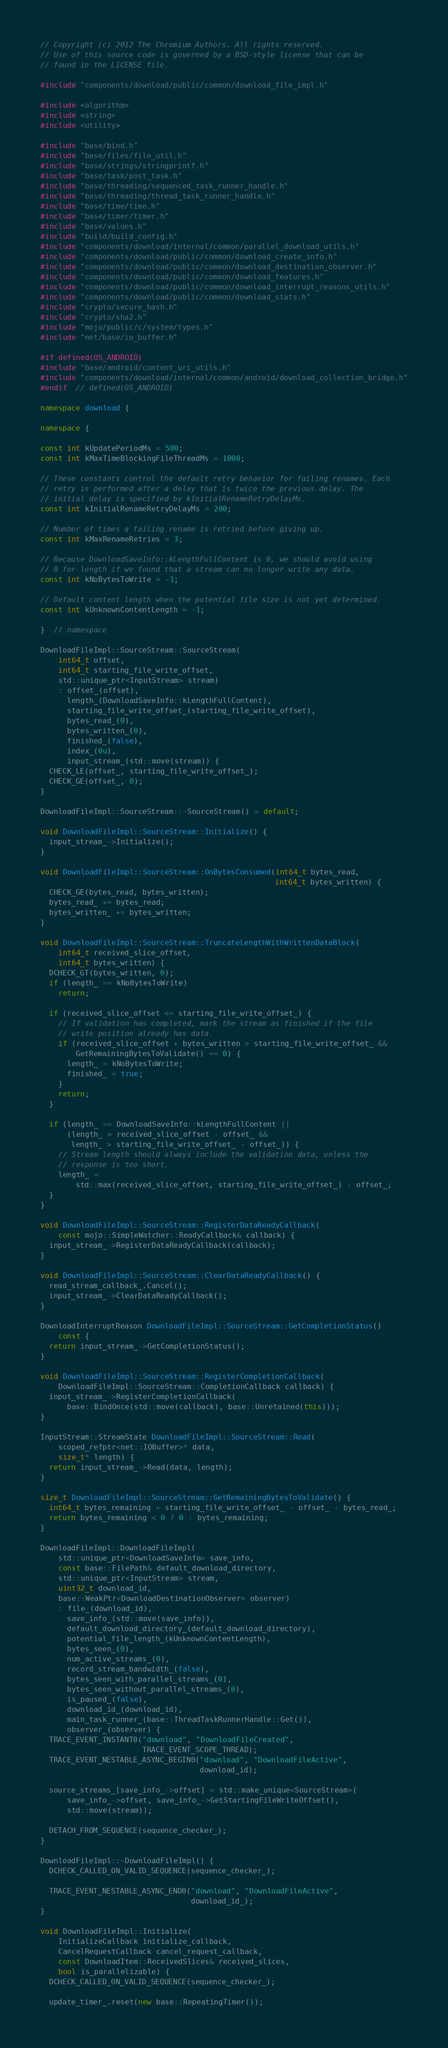Convert code to text. <code><loc_0><loc_0><loc_500><loc_500><_C++_>// Copyright (c) 2012 The Chromium Authors. All rights reserved.
// Use of this source code is governed by a BSD-style license that can be
// found in the LICENSE file.

#include "components/download/public/common/download_file_impl.h"

#include <algorithm>
#include <string>
#include <utility>

#include "base/bind.h"
#include "base/files/file_util.h"
#include "base/strings/stringprintf.h"
#include "base/task/post_task.h"
#include "base/threading/sequenced_task_runner_handle.h"
#include "base/threading/thread_task_runner_handle.h"
#include "base/time/time.h"
#include "base/timer/timer.h"
#include "base/values.h"
#include "build/build_config.h"
#include "components/download/internal/common/parallel_download_utils.h"
#include "components/download/public/common/download_create_info.h"
#include "components/download/public/common/download_destination_observer.h"
#include "components/download/public/common/download_features.h"
#include "components/download/public/common/download_interrupt_reasons_utils.h"
#include "components/download/public/common/download_stats.h"
#include "crypto/secure_hash.h"
#include "crypto/sha2.h"
#include "mojo/public/c/system/types.h"
#include "net/base/io_buffer.h"

#if defined(OS_ANDROID)
#include "base/android/content_uri_utils.h"
#include "components/download/internal/common/android/download_collection_bridge.h"
#endif  // defined(OS_ANDROID)

namespace download {

namespace {

const int kUpdatePeriodMs = 500;
const int kMaxTimeBlockingFileThreadMs = 1000;

// These constants control the default retry behavior for failing renames. Each
// retry is performed after a delay that is twice the previous delay. The
// initial delay is specified by kInitialRenameRetryDelayMs.
const int kInitialRenameRetryDelayMs = 200;

// Number of times a failing rename is retried before giving up.
const int kMaxRenameRetries = 3;

// Because DownloadSaveInfo::kLengthFullContent is 0, we should avoid using
// 0 for length if we found that a stream can no longer write any data.
const int kNoBytesToWrite = -1;

// Default content length when the potential file size is not yet determined.
const int kUnknownContentLength = -1;

}  // namespace

DownloadFileImpl::SourceStream::SourceStream(
    int64_t offset,
    int64_t starting_file_write_offset,
    std::unique_ptr<InputStream> stream)
    : offset_(offset),
      length_(DownloadSaveInfo::kLengthFullContent),
      starting_file_write_offset_(starting_file_write_offset),
      bytes_read_(0),
      bytes_written_(0),
      finished_(false),
      index_(0u),
      input_stream_(std::move(stream)) {
  CHECK_LE(offset_, starting_file_write_offset_);
  CHECK_GE(offset_, 0);
}

DownloadFileImpl::SourceStream::~SourceStream() = default;

void DownloadFileImpl::SourceStream::Initialize() {
  input_stream_->Initialize();
}

void DownloadFileImpl::SourceStream::OnBytesConsumed(int64_t bytes_read,
                                                     int64_t bytes_written) {
  CHECK_GE(bytes_read, bytes_written);
  bytes_read_ += bytes_read;
  bytes_written_ += bytes_written;
}

void DownloadFileImpl::SourceStream::TruncateLengthWithWrittenDataBlock(
    int64_t received_slice_offset,
    int64_t bytes_written) {
  DCHECK_GT(bytes_written, 0);
  if (length_ == kNoBytesToWrite)
    return;

  if (received_slice_offset <= starting_file_write_offset_) {
    // If validation has completed, mark the stream as finished if the file
    // write position already has data.
    if (received_slice_offset + bytes_written > starting_file_write_offset_ &&
        GetRemainingBytesToValidate() == 0) {
      length_ = kNoBytesToWrite;
      finished_ = true;
    }
    return;
  }

  if (length_ == DownloadSaveInfo::kLengthFullContent ||
      (length_ > received_slice_offset - offset_ &&
       length_ > starting_file_write_offset_ - offset_)) {
    // Stream length should always include the validation data, unless the
    // response is too short.
    length_ =
        std::max(received_slice_offset, starting_file_write_offset_) - offset_;
  }
}

void DownloadFileImpl::SourceStream::RegisterDataReadyCallback(
    const mojo::SimpleWatcher::ReadyCallback& callback) {
  input_stream_->RegisterDataReadyCallback(callback);
}

void DownloadFileImpl::SourceStream::ClearDataReadyCallback() {
  read_stream_callback_.Cancel();
  input_stream_->ClearDataReadyCallback();
}

DownloadInterruptReason DownloadFileImpl::SourceStream::GetCompletionStatus()
    const {
  return input_stream_->GetCompletionStatus();
}

void DownloadFileImpl::SourceStream::RegisterCompletionCallback(
    DownloadFileImpl::SourceStream::CompletionCallback callback) {
  input_stream_->RegisterCompletionCallback(
      base::BindOnce(std::move(callback), base::Unretained(this)));
}

InputStream::StreamState DownloadFileImpl::SourceStream::Read(
    scoped_refptr<net::IOBuffer>* data,
    size_t* length) {
  return input_stream_->Read(data, length);
}

size_t DownloadFileImpl::SourceStream::GetRemainingBytesToValidate() {
  int64_t bytes_remaining = starting_file_write_offset_ - offset_ - bytes_read_;
  return bytes_remaining < 0 ? 0 : bytes_remaining;
}

DownloadFileImpl::DownloadFileImpl(
    std::unique_ptr<DownloadSaveInfo> save_info,
    const base::FilePath& default_download_directory,
    std::unique_ptr<InputStream> stream,
    uint32_t download_id,
    base::WeakPtr<DownloadDestinationObserver> observer)
    : file_(download_id),
      save_info_(std::move(save_info)),
      default_download_directory_(default_download_directory),
      potential_file_length_(kUnknownContentLength),
      bytes_seen_(0),
      num_active_streams_(0),
      record_stream_bandwidth_(false),
      bytes_seen_with_parallel_streams_(0),
      bytes_seen_without_parallel_streams_(0),
      is_paused_(false),
      download_id_(download_id),
      main_task_runner_(base::ThreadTaskRunnerHandle::Get()),
      observer_(observer) {
  TRACE_EVENT_INSTANT0("download", "DownloadFileCreated",
                       TRACE_EVENT_SCOPE_THREAD);
  TRACE_EVENT_NESTABLE_ASYNC_BEGIN0("download", "DownloadFileActive",
                                    download_id);

  source_streams_[save_info_->offset] = std::make_unique<SourceStream>(
      save_info_->offset, save_info_->GetStartingFileWriteOffset(),
      std::move(stream));

  DETACH_FROM_SEQUENCE(sequence_checker_);
}

DownloadFileImpl::~DownloadFileImpl() {
  DCHECK_CALLED_ON_VALID_SEQUENCE(sequence_checker_);

  TRACE_EVENT_NESTABLE_ASYNC_END0("download", "DownloadFileActive",
                                  download_id_);
}

void DownloadFileImpl::Initialize(
    InitializeCallback initialize_callback,
    CancelRequestCallback cancel_request_callback,
    const DownloadItem::ReceivedSlices& received_slices,
    bool is_parallelizable) {
  DCHECK_CALLED_ON_VALID_SEQUENCE(sequence_checker_);

  update_timer_.reset(new base::RepeatingTimer());</code> 